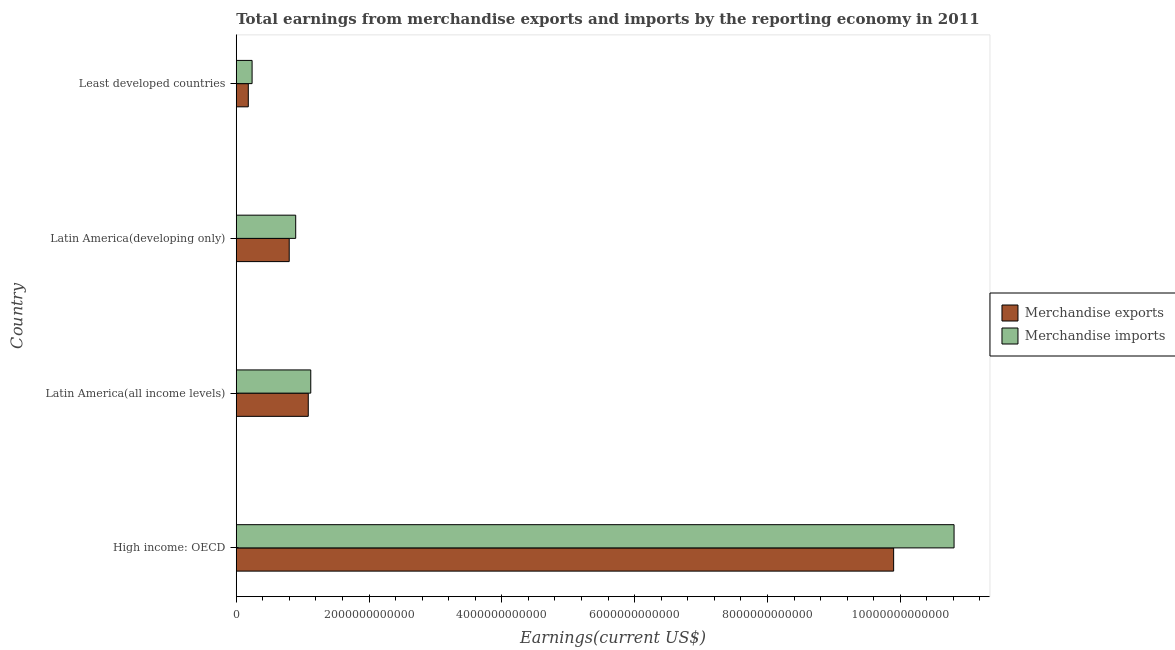How many groups of bars are there?
Keep it short and to the point. 4. Are the number of bars per tick equal to the number of legend labels?
Offer a terse response. Yes. Are the number of bars on each tick of the Y-axis equal?
Your response must be concise. Yes. How many bars are there on the 2nd tick from the top?
Provide a short and direct response. 2. What is the label of the 1st group of bars from the top?
Offer a very short reply. Least developed countries. What is the earnings from merchandise exports in Latin America(all income levels)?
Your answer should be compact. 1.08e+12. Across all countries, what is the maximum earnings from merchandise exports?
Your response must be concise. 9.90e+12. Across all countries, what is the minimum earnings from merchandise imports?
Keep it short and to the point. 2.38e+11. In which country was the earnings from merchandise exports maximum?
Your answer should be very brief. High income: OECD. In which country was the earnings from merchandise exports minimum?
Your answer should be very brief. Least developed countries. What is the total earnings from merchandise exports in the graph?
Your answer should be very brief. 1.20e+13. What is the difference between the earnings from merchandise imports in High income: OECD and that in Latin America(developing only)?
Keep it short and to the point. 9.91e+12. What is the difference between the earnings from merchandise exports in Least developed countries and the earnings from merchandise imports in Latin America(all income levels)?
Keep it short and to the point. -9.41e+11. What is the average earnings from merchandise exports per country?
Your response must be concise. 2.99e+12. What is the difference between the earnings from merchandise imports and earnings from merchandise exports in High income: OECD?
Your answer should be very brief. 9.10e+11. What is the ratio of the earnings from merchandise exports in High income: OECD to that in Latin America(all income levels)?
Keep it short and to the point. 9.13. What is the difference between the highest and the second highest earnings from merchandise exports?
Give a very brief answer. 8.82e+12. What is the difference between the highest and the lowest earnings from merchandise exports?
Your answer should be compact. 9.72e+12. In how many countries, is the earnings from merchandise exports greater than the average earnings from merchandise exports taken over all countries?
Keep it short and to the point. 1. Is the sum of the earnings from merchandise exports in High income: OECD and Least developed countries greater than the maximum earnings from merchandise imports across all countries?
Ensure brevity in your answer.  No. What does the 2nd bar from the top in Latin America(developing only) represents?
Keep it short and to the point. Merchandise exports. How many countries are there in the graph?
Make the answer very short. 4. What is the difference between two consecutive major ticks on the X-axis?
Offer a very short reply. 2.00e+12. Are the values on the major ticks of X-axis written in scientific E-notation?
Make the answer very short. No. What is the title of the graph?
Offer a very short reply. Total earnings from merchandise exports and imports by the reporting economy in 2011. Does "Private credit bureau" appear as one of the legend labels in the graph?
Make the answer very short. No. What is the label or title of the X-axis?
Offer a very short reply. Earnings(current US$). What is the Earnings(current US$) in Merchandise exports in High income: OECD?
Make the answer very short. 9.90e+12. What is the Earnings(current US$) in Merchandise imports in High income: OECD?
Your answer should be very brief. 1.08e+13. What is the Earnings(current US$) of Merchandise exports in Latin America(all income levels)?
Your response must be concise. 1.08e+12. What is the Earnings(current US$) in Merchandise imports in Latin America(all income levels)?
Your answer should be very brief. 1.12e+12. What is the Earnings(current US$) of Merchandise exports in Latin America(developing only)?
Ensure brevity in your answer.  7.98e+11. What is the Earnings(current US$) in Merchandise imports in Latin America(developing only)?
Provide a short and direct response. 8.95e+11. What is the Earnings(current US$) in Merchandise exports in Least developed countries?
Offer a very short reply. 1.81e+11. What is the Earnings(current US$) in Merchandise imports in Least developed countries?
Offer a terse response. 2.38e+11. Across all countries, what is the maximum Earnings(current US$) in Merchandise exports?
Give a very brief answer. 9.90e+12. Across all countries, what is the maximum Earnings(current US$) in Merchandise imports?
Offer a terse response. 1.08e+13. Across all countries, what is the minimum Earnings(current US$) of Merchandise exports?
Offer a very short reply. 1.81e+11. Across all countries, what is the minimum Earnings(current US$) in Merchandise imports?
Your answer should be very brief. 2.38e+11. What is the total Earnings(current US$) in Merchandise exports in the graph?
Offer a very short reply. 1.20e+13. What is the total Earnings(current US$) of Merchandise imports in the graph?
Your answer should be very brief. 1.31e+13. What is the difference between the Earnings(current US$) in Merchandise exports in High income: OECD and that in Latin America(all income levels)?
Offer a terse response. 8.82e+12. What is the difference between the Earnings(current US$) in Merchandise imports in High income: OECD and that in Latin America(all income levels)?
Give a very brief answer. 9.69e+12. What is the difference between the Earnings(current US$) in Merchandise exports in High income: OECD and that in Latin America(developing only)?
Your answer should be compact. 9.10e+12. What is the difference between the Earnings(current US$) in Merchandise imports in High income: OECD and that in Latin America(developing only)?
Give a very brief answer. 9.91e+12. What is the difference between the Earnings(current US$) of Merchandise exports in High income: OECD and that in Least developed countries?
Ensure brevity in your answer.  9.72e+12. What is the difference between the Earnings(current US$) in Merchandise imports in High income: OECD and that in Least developed countries?
Your answer should be very brief. 1.06e+13. What is the difference between the Earnings(current US$) of Merchandise exports in Latin America(all income levels) and that in Latin America(developing only)?
Make the answer very short. 2.87e+11. What is the difference between the Earnings(current US$) in Merchandise imports in Latin America(all income levels) and that in Latin America(developing only)?
Give a very brief answer. 2.27e+11. What is the difference between the Earnings(current US$) of Merchandise exports in Latin America(all income levels) and that in Least developed countries?
Provide a succinct answer. 9.03e+11. What is the difference between the Earnings(current US$) of Merchandise imports in Latin America(all income levels) and that in Least developed countries?
Give a very brief answer. 8.84e+11. What is the difference between the Earnings(current US$) of Merchandise exports in Latin America(developing only) and that in Least developed countries?
Ensure brevity in your answer.  6.16e+11. What is the difference between the Earnings(current US$) of Merchandise imports in Latin America(developing only) and that in Least developed countries?
Make the answer very short. 6.57e+11. What is the difference between the Earnings(current US$) in Merchandise exports in High income: OECD and the Earnings(current US$) in Merchandise imports in Latin America(all income levels)?
Your response must be concise. 8.78e+12. What is the difference between the Earnings(current US$) in Merchandise exports in High income: OECD and the Earnings(current US$) in Merchandise imports in Latin America(developing only)?
Keep it short and to the point. 9.00e+12. What is the difference between the Earnings(current US$) of Merchandise exports in High income: OECD and the Earnings(current US$) of Merchandise imports in Least developed countries?
Make the answer very short. 9.66e+12. What is the difference between the Earnings(current US$) of Merchandise exports in Latin America(all income levels) and the Earnings(current US$) of Merchandise imports in Latin America(developing only)?
Ensure brevity in your answer.  1.89e+11. What is the difference between the Earnings(current US$) in Merchandise exports in Latin America(all income levels) and the Earnings(current US$) in Merchandise imports in Least developed countries?
Provide a short and direct response. 8.46e+11. What is the difference between the Earnings(current US$) in Merchandise exports in Latin America(developing only) and the Earnings(current US$) in Merchandise imports in Least developed countries?
Offer a very short reply. 5.59e+11. What is the average Earnings(current US$) in Merchandise exports per country?
Your answer should be compact. 2.99e+12. What is the average Earnings(current US$) of Merchandise imports per country?
Your answer should be compact. 3.27e+12. What is the difference between the Earnings(current US$) in Merchandise exports and Earnings(current US$) in Merchandise imports in High income: OECD?
Offer a very short reply. -9.10e+11. What is the difference between the Earnings(current US$) in Merchandise exports and Earnings(current US$) in Merchandise imports in Latin America(all income levels)?
Provide a succinct answer. -3.77e+1. What is the difference between the Earnings(current US$) in Merchandise exports and Earnings(current US$) in Merchandise imports in Latin America(developing only)?
Offer a terse response. -9.76e+1. What is the difference between the Earnings(current US$) in Merchandise exports and Earnings(current US$) in Merchandise imports in Least developed countries?
Your answer should be very brief. -5.72e+1. What is the ratio of the Earnings(current US$) in Merchandise exports in High income: OECD to that in Latin America(all income levels)?
Offer a very short reply. 9.13. What is the ratio of the Earnings(current US$) of Merchandise imports in High income: OECD to that in Latin America(all income levels)?
Make the answer very short. 9.63. What is the ratio of the Earnings(current US$) of Merchandise exports in High income: OECD to that in Latin America(developing only)?
Your response must be concise. 12.41. What is the ratio of the Earnings(current US$) in Merchandise imports in High income: OECD to that in Latin America(developing only)?
Your answer should be compact. 12.07. What is the ratio of the Earnings(current US$) of Merchandise exports in High income: OECD to that in Least developed countries?
Ensure brevity in your answer.  54.6. What is the ratio of the Earnings(current US$) in Merchandise imports in High income: OECD to that in Least developed countries?
Offer a terse response. 45.33. What is the ratio of the Earnings(current US$) of Merchandise exports in Latin America(all income levels) to that in Latin America(developing only)?
Your answer should be very brief. 1.36. What is the ratio of the Earnings(current US$) of Merchandise imports in Latin America(all income levels) to that in Latin America(developing only)?
Offer a terse response. 1.25. What is the ratio of the Earnings(current US$) of Merchandise exports in Latin America(all income levels) to that in Least developed countries?
Make the answer very short. 5.98. What is the ratio of the Earnings(current US$) of Merchandise imports in Latin America(all income levels) to that in Least developed countries?
Offer a very short reply. 4.71. What is the ratio of the Earnings(current US$) of Merchandise exports in Latin America(developing only) to that in Least developed countries?
Keep it short and to the point. 4.4. What is the ratio of the Earnings(current US$) in Merchandise imports in Latin America(developing only) to that in Least developed countries?
Provide a short and direct response. 3.75. What is the difference between the highest and the second highest Earnings(current US$) in Merchandise exports?
Offer a very short reply. 8.82e+12. What is the difference between the highest and the second highest Earnings(current US$) in Merchandise imports?
Give a very brief answer. 9.69e+12. What is the difference between the highest and the lowest Earnings(current US$) in Merchandise exports?
Offer a very short reply. 9.72e+12. What is the difference between the highest and the lowest Earnings(current US$) in Merchandise imports?
Offer a terse response. 1.06e+13. 